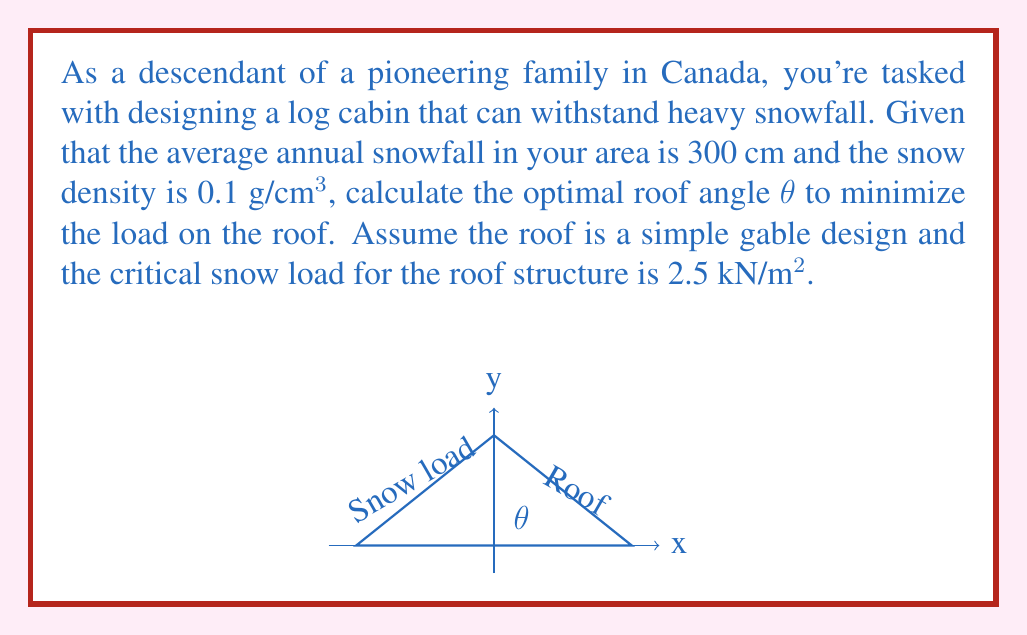Could you help me with this problem? Let's approach this step-by-step:

1) First, we need to calculate the weight of the snow per square meter:
   $$ \text{Snow weight} = 300 \text{ cm} \times 0.1 \text{ g/cm³} \times 10000 \text{ cm²/m²} \times 9.81 \text{ m/s²} = 2943 \text{ N/m²} $$

2) The normal force on the roof depends on the angle θ:
   $$ F_n = 2943 \cos(\theta) \text{ N/m²} $$

3) We want this normal force to be equal to the critical snow load:
   $$ 2943 \cos(\theta) = 2500 $$

4) Solving for θ:
   $$ \cos(\theta) = \frac{2500}{2943} $$
   $$ \theta = \arccos(\frac{2500}{2943}) $$

5) Calculate the angle:
   $$ \theta \approx 32.1° $$

6) To minimize the load, we should choose an angle slightly larger than this. A common rule of thumb is to add about 10% to this angle for safety and to account for other factors. 

Therefore, the optimal angle would be approximately 35°.
Answer: 35° 